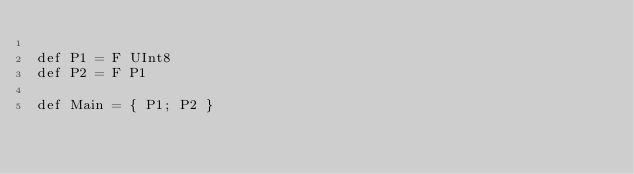<code> <loc_0><loc_0><loc_500><loc_500><_SQL_>
def P1 = F UInt8
def P2 = F P1

def Main = { P1; P2 }
</code> 